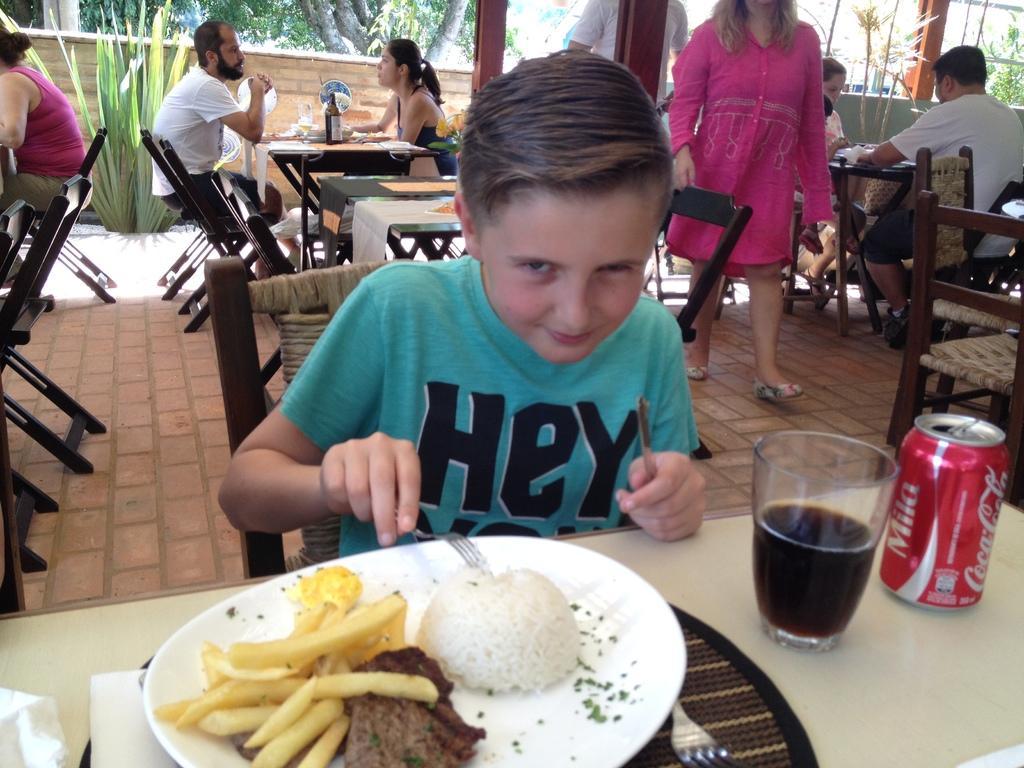In one or two sentences, can you explain what this image depicts? on the table there is a plate in which there are food items and a glass and a tin. a person is eating that food, holding a fork and a knife in his hand. behind him there tables and chairs and people are seated. from the left people are entering inside. at the back there's a wall and trees. 